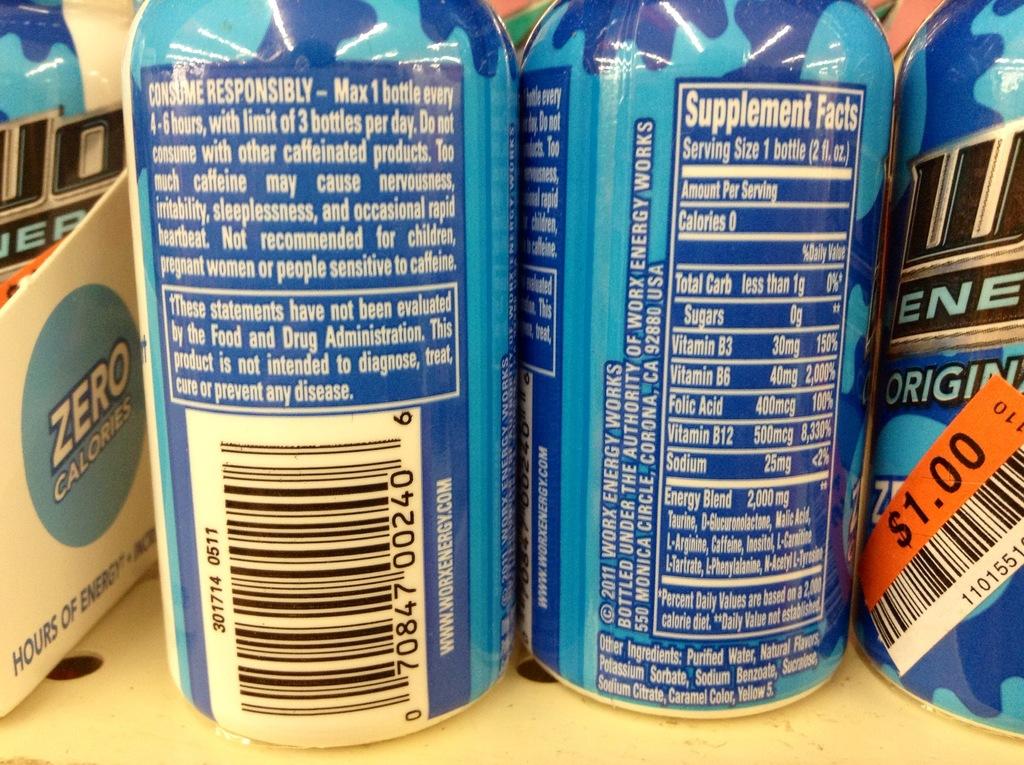How much is this drink?
Give a very brief answer. $1.00. 